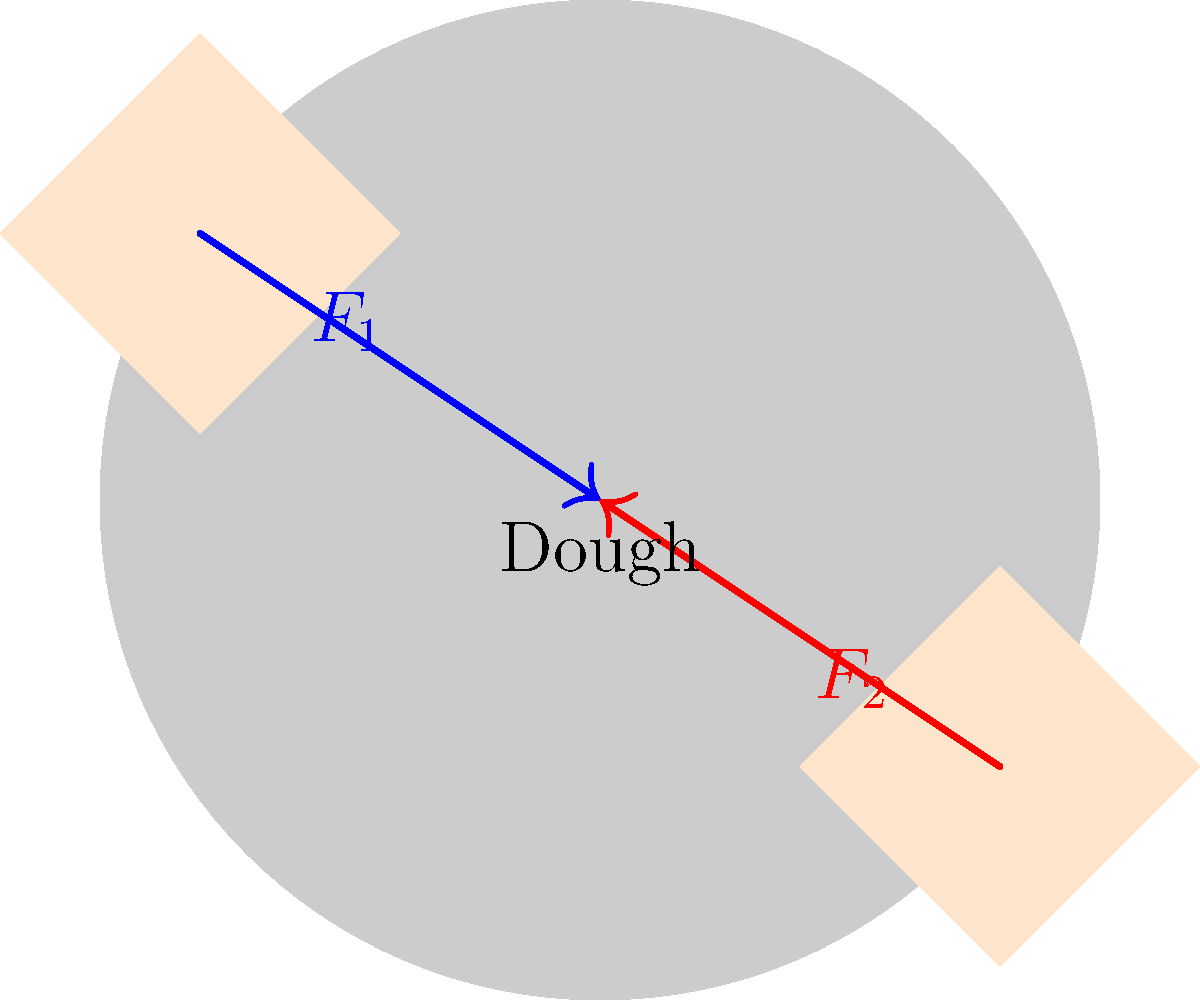Your mom's kneading some sick pizza dough for your squad tonight. She's applying two forces, $F_1$ and $F_2$, on opposite sides of the dough. If $F_1 = 50\text{ N}$ at a $30^\circ$ angle to the horizontal, and $F_2 = 40\text{ N}$ at a $45^\circ$ angle to the horizontal in the opposite direction, what's the magnitude of the net force on the dough? Let's break this down step by step:

1) First, we need to resolve each force into its horizontal and vertical components.

   For $F_1$:
   $F_{1x} = 50 \cos(30^\circ) = 50 \cdot \frac{\sqrt{3}}{2} = 25\sqrt{3}\text{ N}$
   $F_{1y} = 50 \sin(30^\circ) = 50 \cdot \frac{1}{2} = 25\text{ N}$

   For $F_2$:
   $F_{2x} = 40 \cos(45^\circ) = 40 \cdot \frac{\sqrt{2}}{2} = 20\sqrt{2}\text{ N}$
   $F_{2y} = 40 \sin(45^\circ) = 40 \cdot \frac{\sqrt{2}}{2} = 20\sqrt{2}\text{ N}$

2) Now, we need to find the net force in each direction:

   $F_{net_x} = F_{1x} - F_{2x} = 25\sqrt{3} - 20\sqrt{2}\text{ N}$
   $F_{net_y} = F_{1y} - F_{2y} = 25 - 20\sqrt{2}\text{ N}$

3) To find the magnitude of the net force, we use the Pythagorean theorem:

   $F_{net} = \sqrt{(F_{net_x})^2 + (F_{net_y})^2}$

4) Substituting our values:

   $F_{net} = \sqrt{(25\sqrt{3} - 20\sqrt{2})^2 + (25 - 20\sqrt{2})^2}$

5) Simplifying inside the parentheses:

   $F_{net} = \sqrt{(43.3 - 28.3)^2 + (25 - 28.3)^2}$
   $F_{net} = \sqrt{15^2 + (-3.3)^2}$
   $F_{net} = \sqrt{225 + 10.89}$
   $F_{net} = \sqrt{235.89}$

6) Taking the square root:

   $F_{net} \approx 15.36\text{ N}$
Answer: 15.36 N 